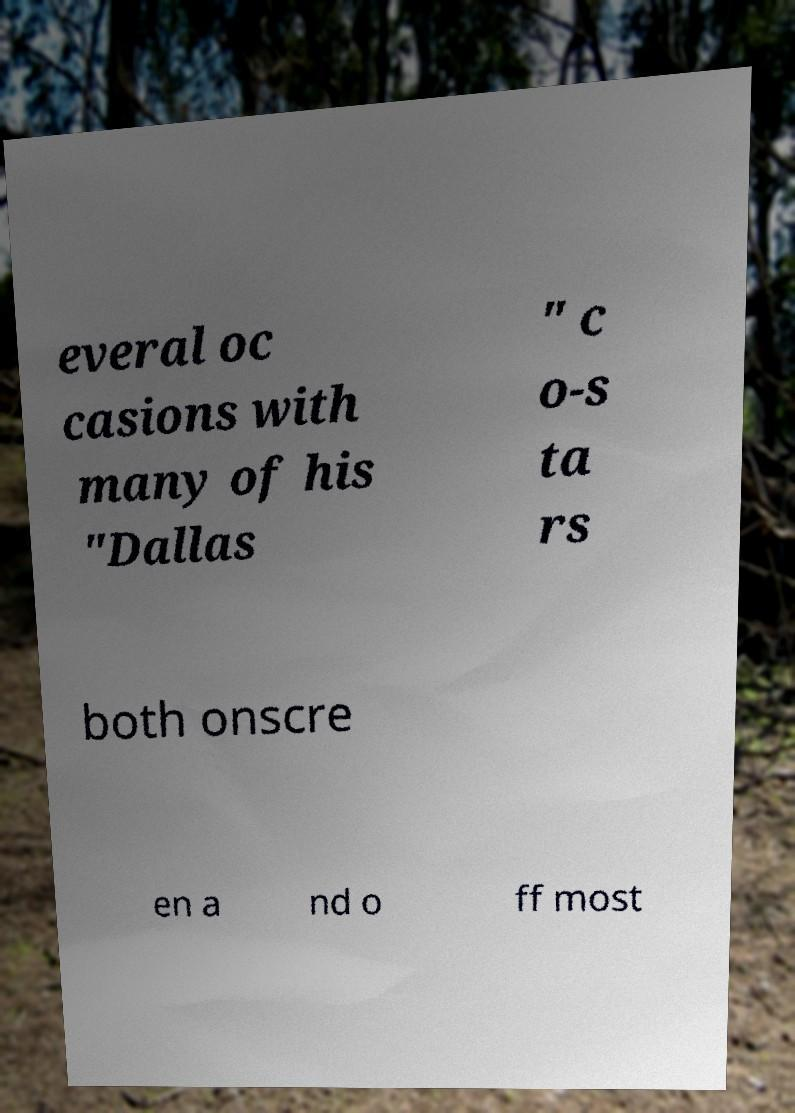Please identify and transcribe the text found in this image. everal oc casions with many of his "Dallas " c o-s ta rs both onscre en a nd o ff most 